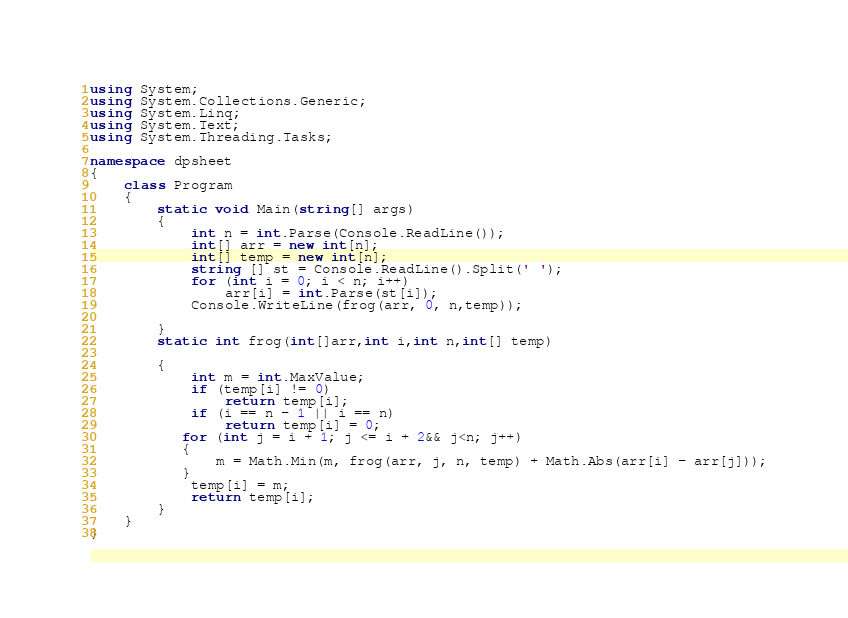Convert code to text. <code><loc_0><loc_0><loc_500><loc_500><_C#_>using System;
using System.Collections.Generic;
using System.Linq;
using System.Text;
using System.Threading.Tasks;

namespace dpsheet
{
    class Program
    {
        static void Main(string[] args)
        {
            int n = int.Parse(Console.ReadLine());
            int[] arr = new int[n];
            int[] temp = new int[n];
            string [] st = Console.ReadLine().Split(' ');
            for (int i = 0; i < n; i++)
                arr[i] = int.Parse(st[i]);
            Console.WriteLine(frog(arr, 0, n,temp));
             
        }
        static int frog(int[]arr,int i,int n,int[] temp)

        {
            int m = int.MaxValue;
            if (temp[i] != 0)
                return temp[i];
            if (i == n - 1 || i == n)
                return temp[i] = 0;
           for (int j = i + 1; j <= i + 2&& j<n; j++)
           {
               m = Math.Min(m, frog(arr, j, n, temp) + Math.Abs(arr[i] - arr[j]));
           }
            temp[i] = m;
            return temp[i];
        }
    }
}
</code> 